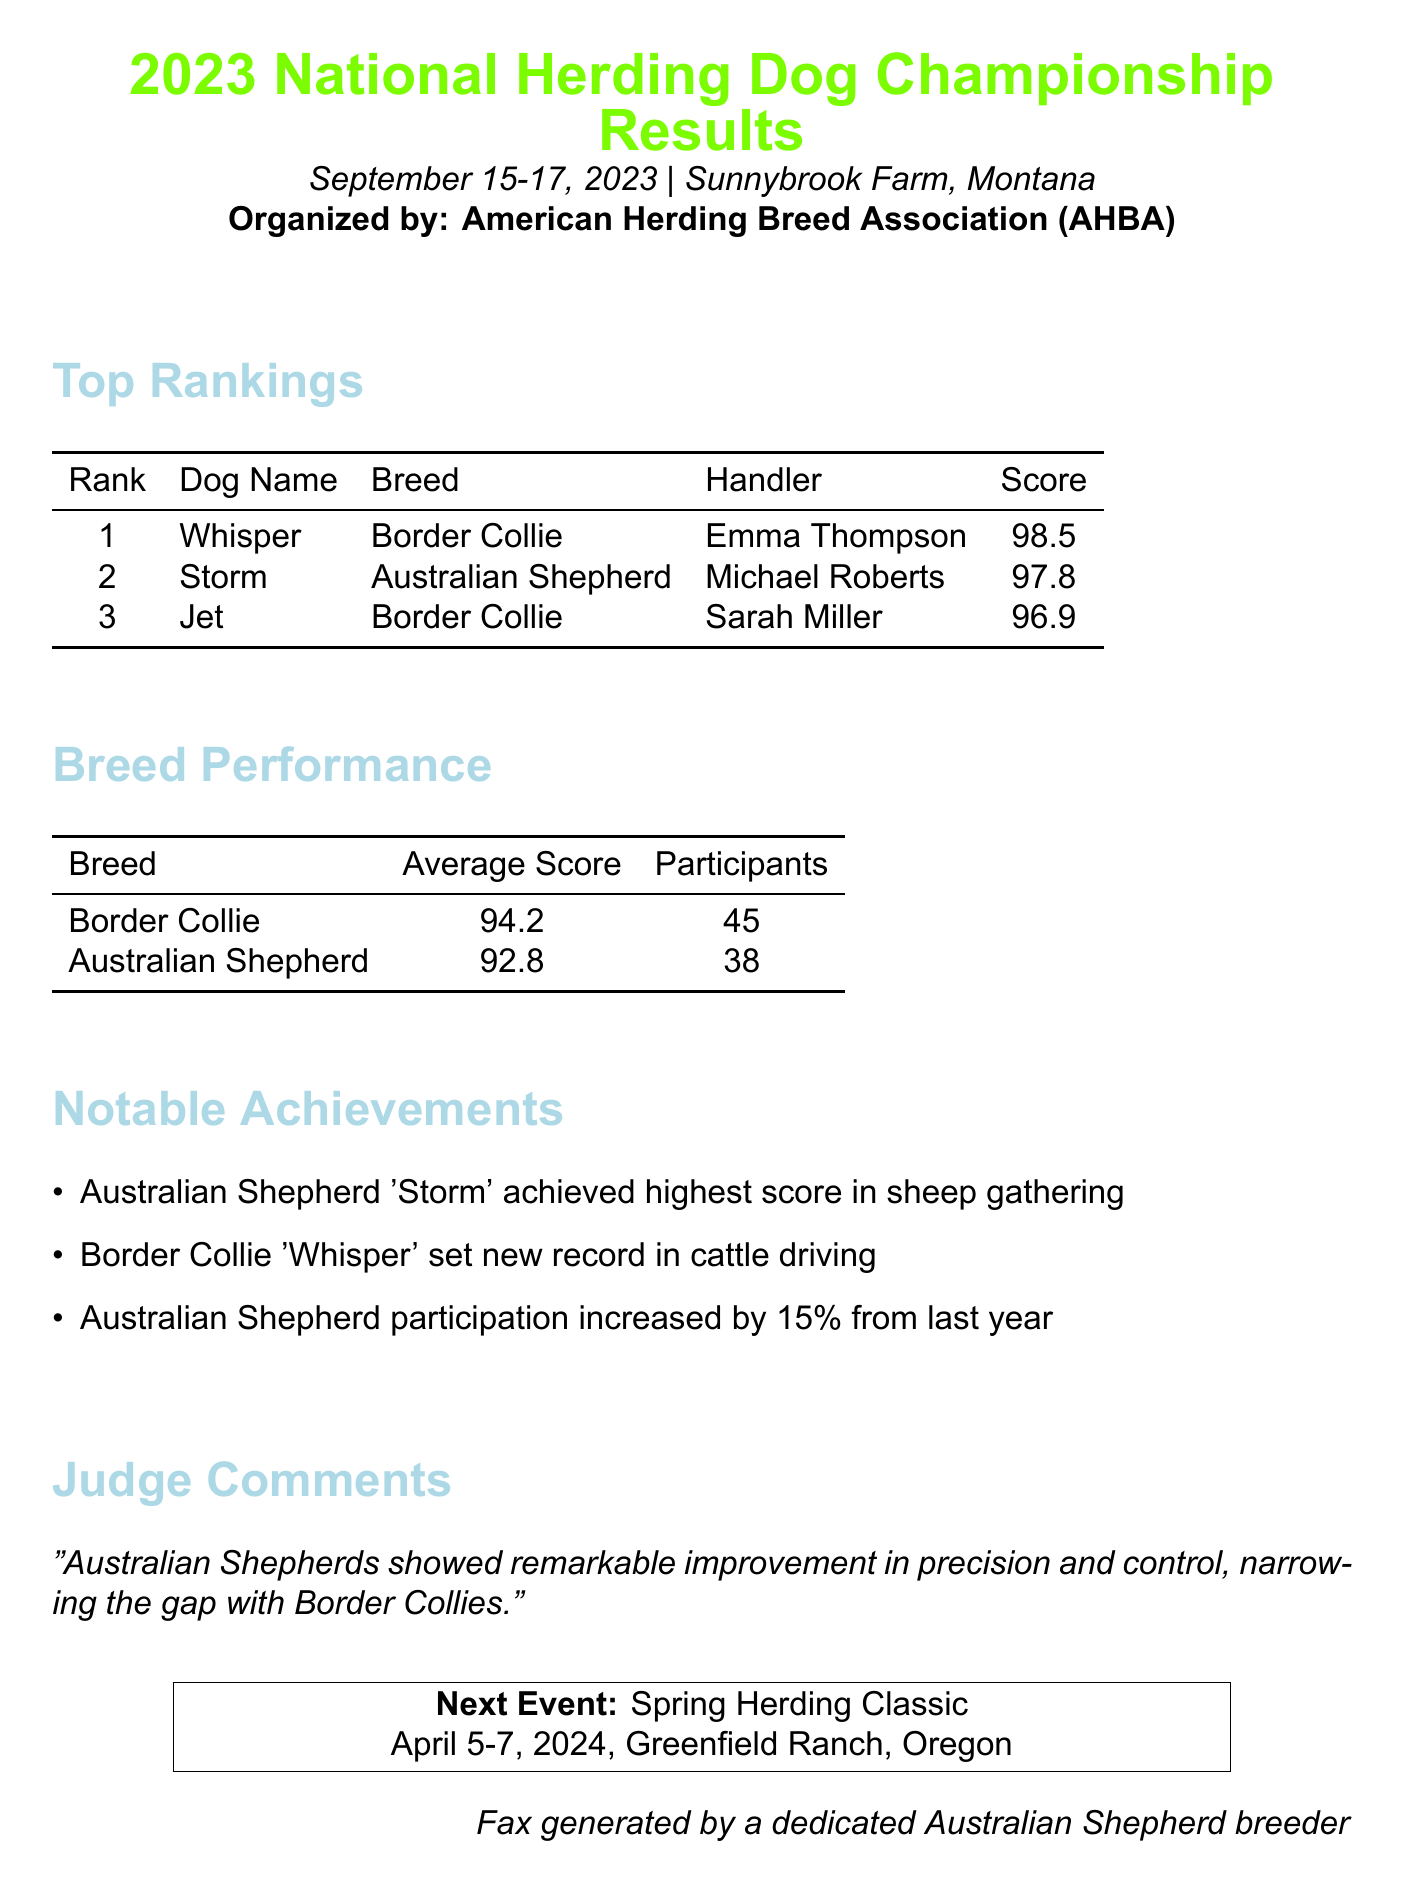what is the date of the competition? The competition took place from September 15 to September 17, 2023.
Answer: September 15-17, 2023 who won the competition? The top-ranking dog was 'Whisper', a Border Collie, who achieved the highest score.
Answer: Whisper what is the average score for Australian Shepherds? The document states that the average score for Australian Shepherds was 92.8.
Answer: 92.8 how many Border Collies participated in the competition? There were a total of 45 Border Collies participating, as shown in the breed performance table.
Answer: 45 which Australian Shepherd had the highest score in sheep gathering? The document highlights that 'Storm' was recognized for achieving the highest score in sheep gathering.
Answer: Storm what was the score of the second-place dog? The second-place dog was 'Storm' who received a score of 97.8.
Answer: 97.8 how much did the participation of Australian Shepherds increase from last year? The document notes a 15% increase in Australian Shepherd participation compared to last year.
Answer: 15% what notable record did 'Whisper' achieve? 'Whisper' set a new record in cattle driving as mentioned in the notable achievements section.
Answer: new record in cattle driving when is the next event scheduled? The next event, the Spring Herding Classic, is scheduled for April 5-7, 2024.
Answer: April 5-7, 2024 